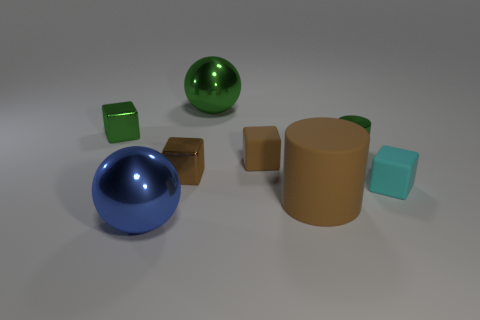Subtract all brown metal cubes. How many cubes are left? 3 Add 1 tiny cylinders. How many objects exist? 9 Subtract all brown cubes. How many cubes are left? 2 Subtract all spheres. How many objects are left? 6 Subtract 2 cylinders. How many cylinders are left? 0 Subtract all tiny metallic cylinders. Subtract all big gray matte objects. How many objects are left? 7 Add 5 large blue spheres. How many large blue spheres are left? 6 Add 8 small cyan cubes. How many small cyan cubes exist? 9 Subtract 0 blue cylinders. How many objects are left? 8 Subtract all cyan cubes. Subtract all cyan spheres. How many cubes are left? 3 